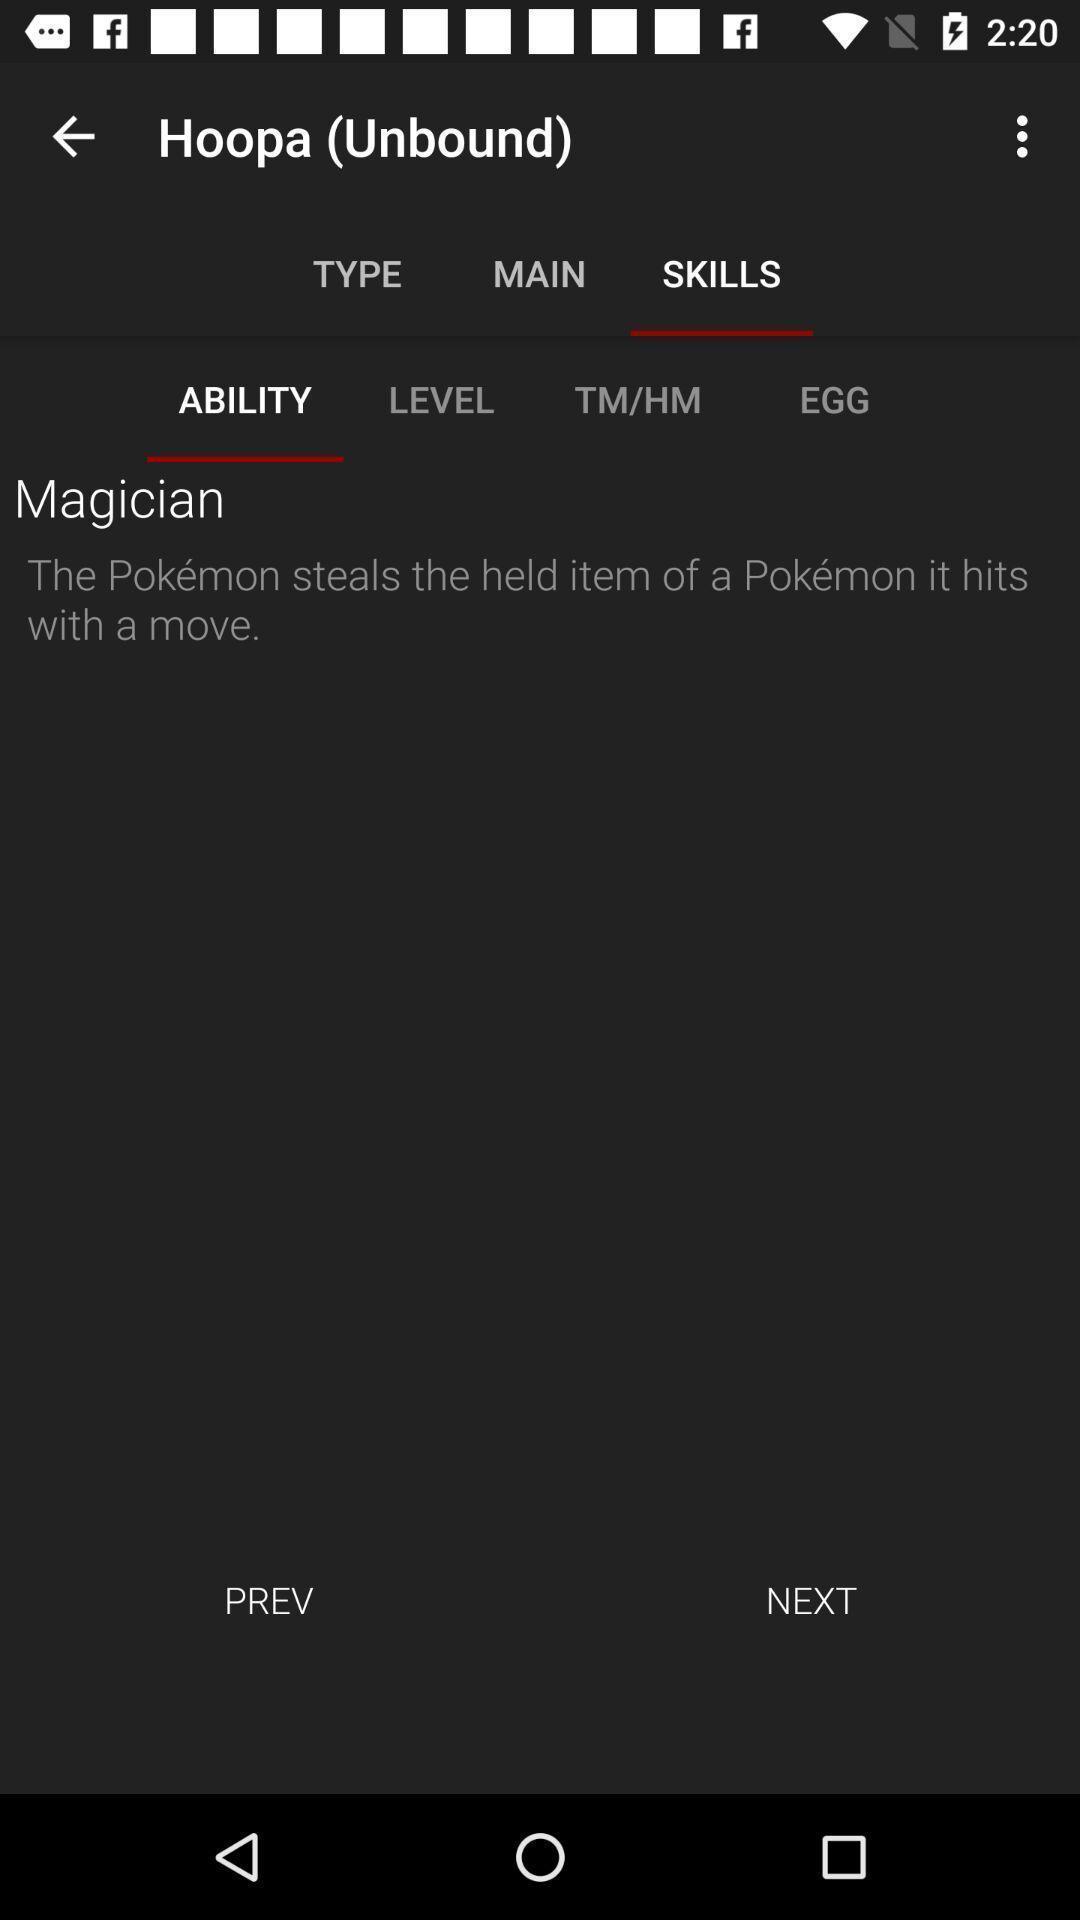What details can you identify in this image? Screen showing ability with next option. 